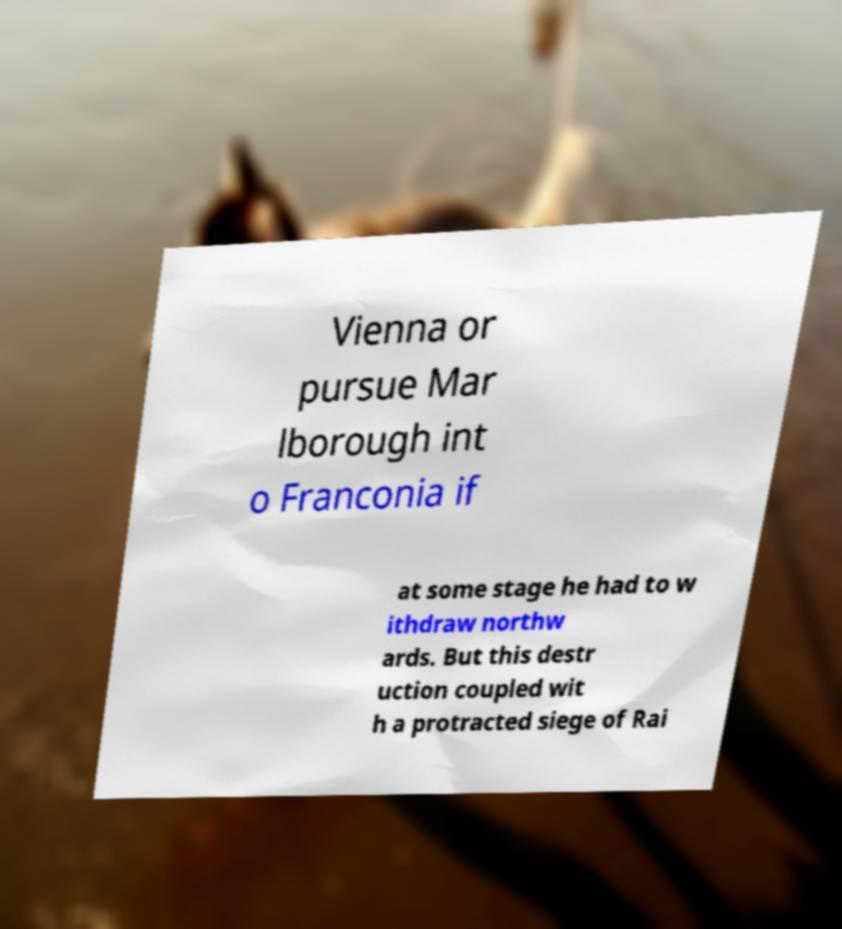For documentation purposes, I need the text within this image transcribed. Could you provide that? Vienna or pursue Mar lborough int o Franconia if at some stage he had to w ithdraw northw ards. But this destr uction coupled wit h a protracted siege of Rai 